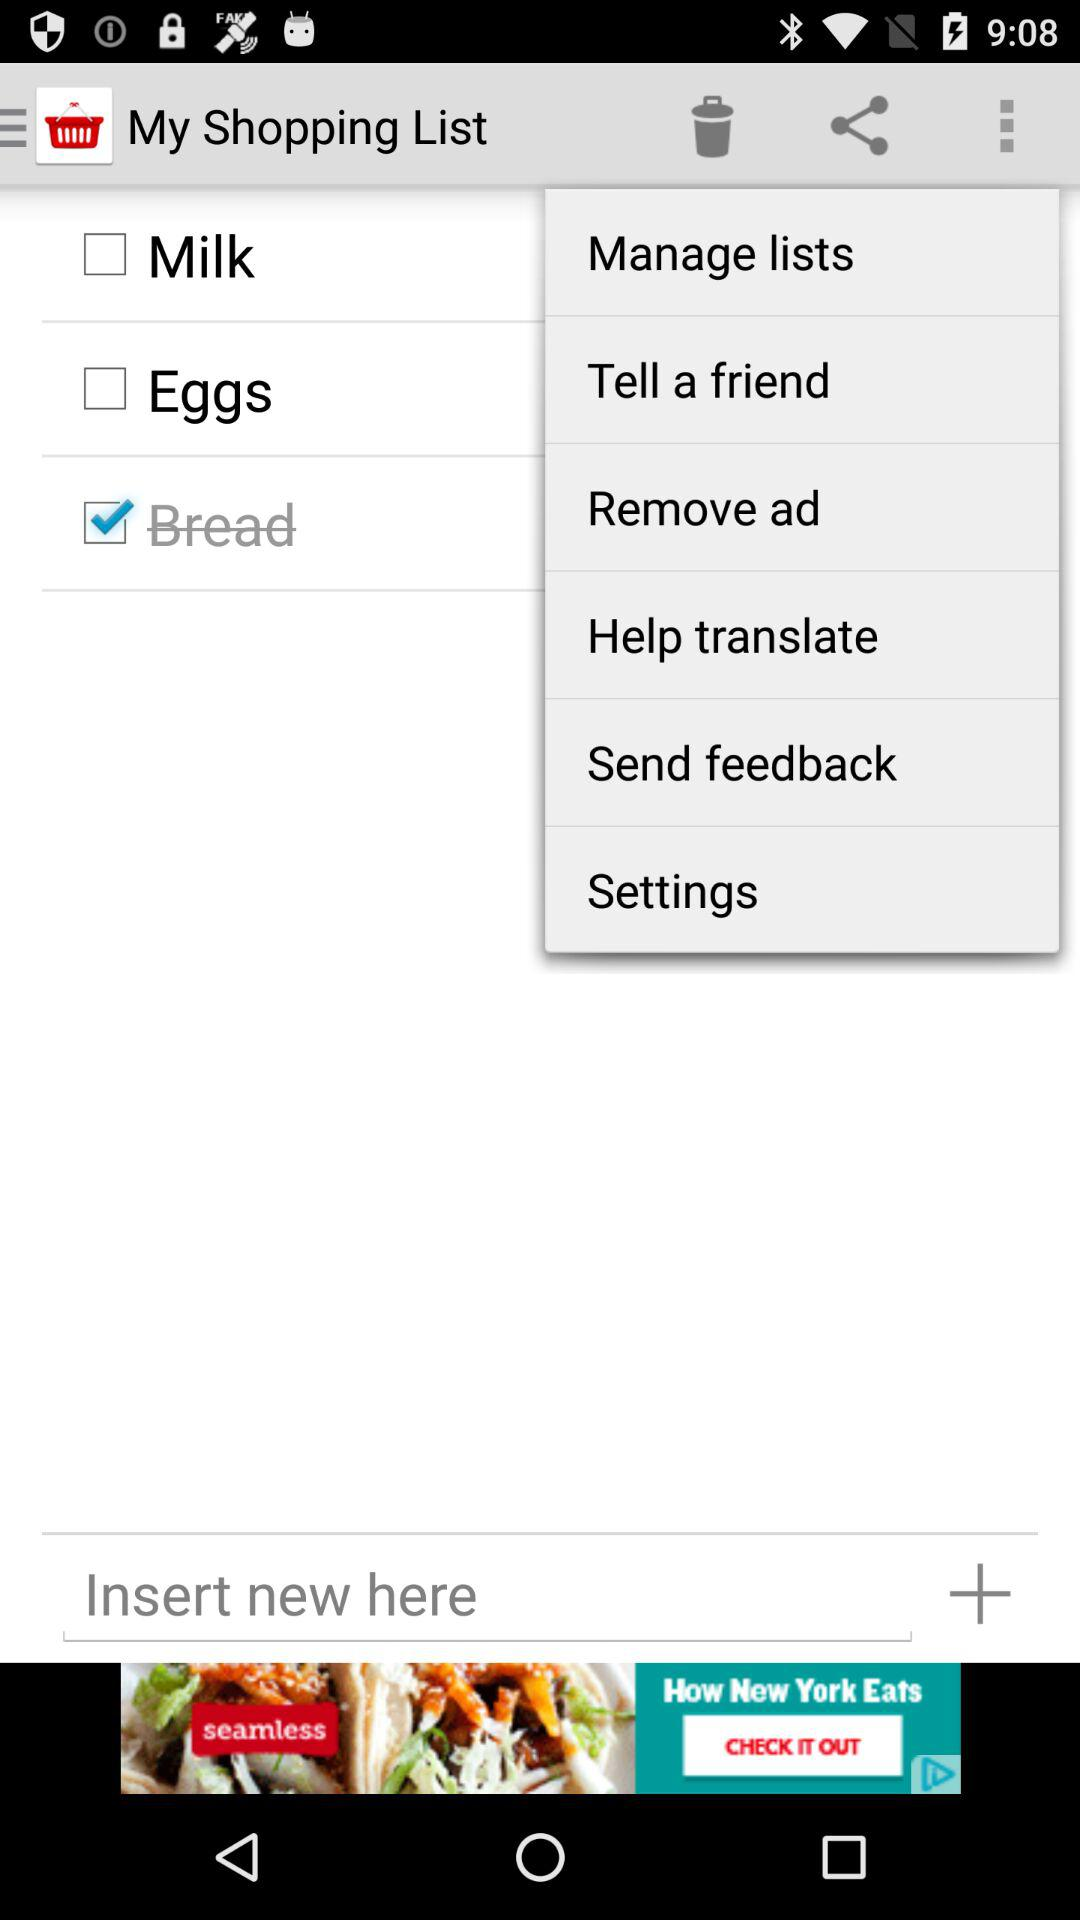Which option was checked? The checked option was "Bread". 